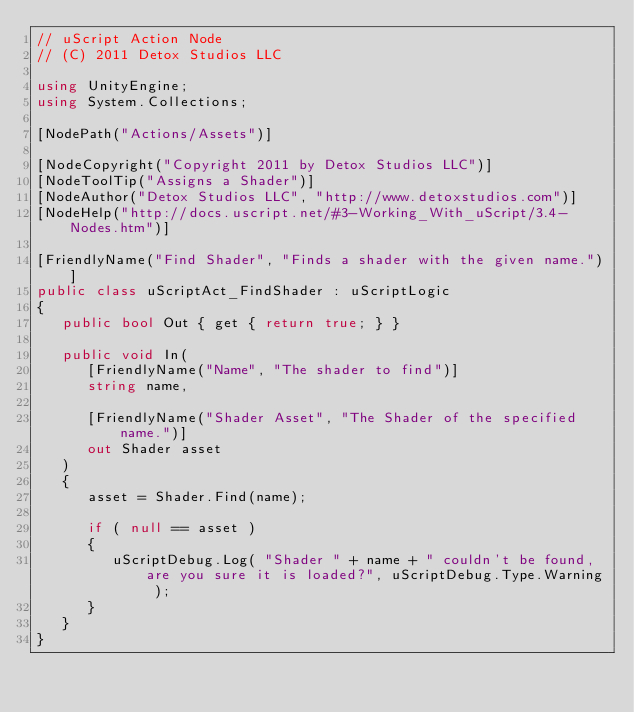Convert code to text. <code><loc_0><loc_0><loc_500><loc_500><_C#_>// uScript Action Node
// (C) 2011 Detox Studios LLC

using UnityEngine;
using System.Collections;

[NodePath("Actions/Assets")]

[NodeCopyright("Copyright 2011 by Detox Studios LLC")]
[NodeToolTip("Assigns a Shader")]
[NodeAuthor("Detox Studios LLC", "http://www.detoxstudios.com")]
[NodeHelp("http://docs.uscript.net/#3-Working_With_uScript/3.4-Nodes.htm")]

[FriendlyName("Find Shader", "Finds a shader with the given name.")]
public class uScriptAct_FindShader : uScriptLogic
{
   public bool Out { get { return true; } }

   public void In(
      [FriendlyName("Name", "The shader to find")]
      string name,

      [FriendlyName("Shader Asset", "The Shader of the specified name.")]
      out Shader asset
   )
   {
      asset = Shader.Find(name);

      if ( null == asset )
      {
         uScriptDebug.Log( "Shader " + name + " couldn't be found, are you sure it is loaded?", uScriptDebug.Type.Warning );
      }
   }
}</code> 